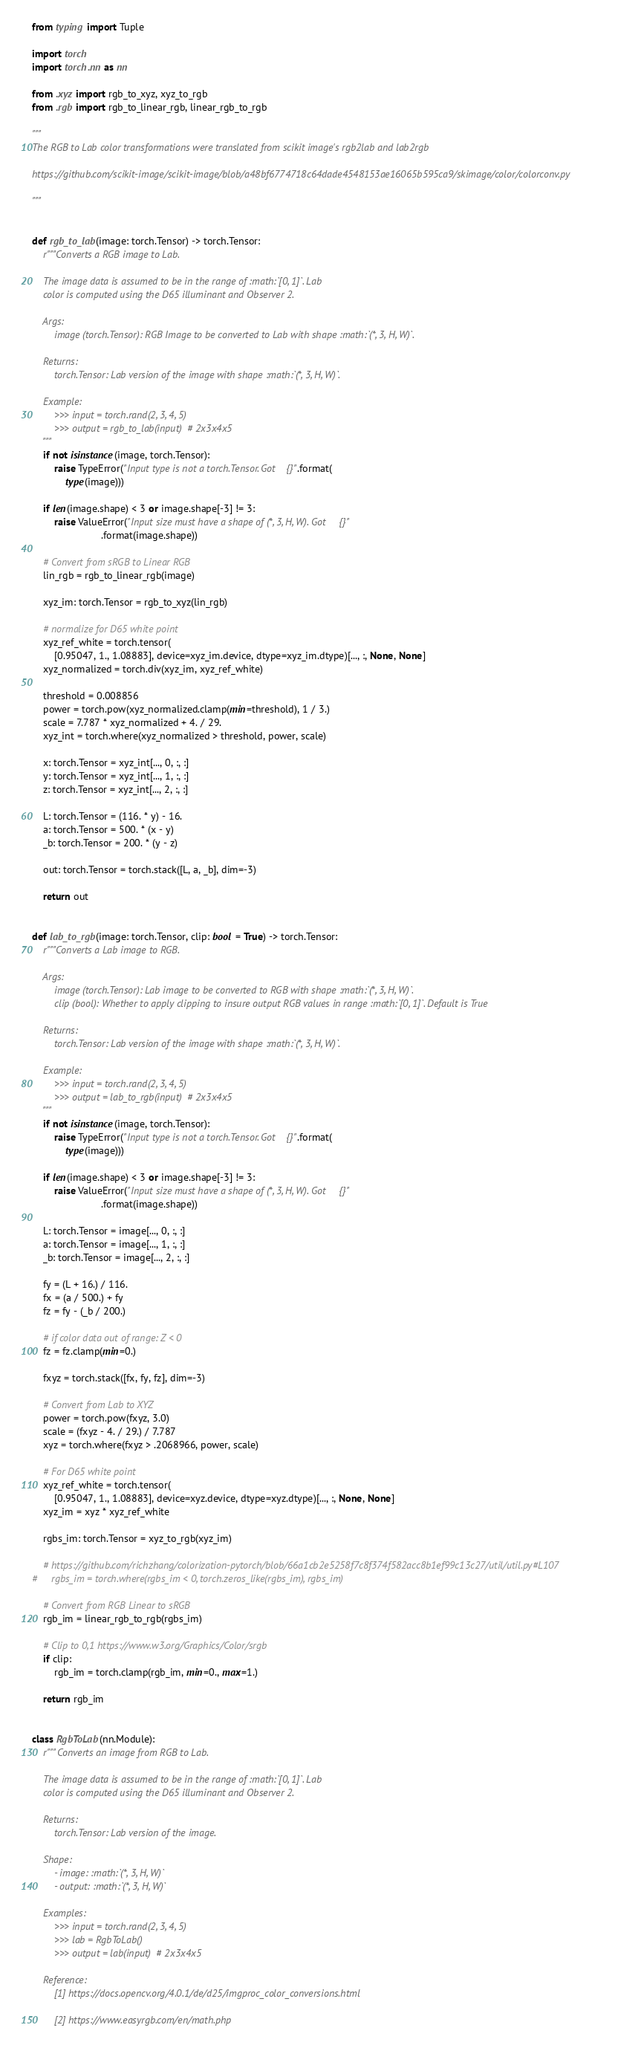<code> <loc_0><loc_0><loc_500><loc_500><_Python_>from typing import Tuple

import torch
import torch.nn as nn

from .xyz import rgb_to_xyz, xyz_to_rgb
from .rgb import rgb_to_linear_rgb, linear_rgb_to_rgb

"""
The RGB to Lab color transformations were translated from scikit image's rgb2lab and lab2rgb

https://github.com/scikit-image/scikit-image/blob/a48bf6774718c64dade4548153ae16065b595ca9/skimage/color/colorconv.py

"""


def rgb_to_lab(image: torch.Tensor) -> torch.Tensor:
    r"""Converts a RGB image to Lab.

    The image data is assumed to be in the range of :math:`[0, 1]`. Lab
    color is computed using the D65 illuminant and Observer 2.

    Args:
        image (torch.Tensor): RGB Image to be converted to Lab with shape :math:`(*, 3, H, W)`.

    Returns:
        torch.Tensor: Lab version of the image with shape :math:`(*, 3, H, W)`.

    Example:
        >>> input = torch.rand(2, 3, 4, 5)
        >>> output = rgb_to_lab(input)  # 2x3x4x5
    """
    if not isinstance(image, torch.Tensor):
        raise TypeError("Input type is not a torch.Tensor. Got {}".format(
            type(image)))

    if len(image.shape) < 3 or image.shape[-3] != 3:
        raise ValueError("Input size must have a shape of (*, 3, H, W). Got {}"
                         .format(image.shape))

    # Convert from sRGB to Linear RGB
    lin_rgb = rgb_to_linear_rgb(image)

    xyz_im: torch.Tensor = rgb_to_xyz(lin_rgb)

    # normalize for D65 white point
    xyz_ref_white = torch.tensor(
        [0.95047, 1., 1.08883], device=xyz_im.device, dtype=xyz_im.dtype)[..., :, None, None]
    xyz_normalized = torch.div(xyz_im, xyz_ref_white)

    threshold = 0.008856
    power = torch.pow(xyz_normalized.clamp(min=threshold), 1 / 3.)
    scale = 7.787 * xyz_normalized + 4. / 29.
    xyz_int = torch.where(xyz_normalized > threshold, power, scale)

    x: torch.Tensor = xyz_int[..., 0, :, :]
    y: torch.Tensor = xyz_int[..., 1, :, :]
    z: torch.Tensor = xyz_int[..., 2, :, :]

    L: torch.Tensor = (116. * y) - 16.
    a: torch.Tensor = 500. * (x - y)
    _b: torch.Tensor = 200. * (y - z)

    out: torch.Tensor = torch.stack([L, a, _b], dim=-3)

    return out


def lab_to_rgb(image: torch.Tensor, clip: bool = True) -> torch.Tensor:
    r"""Converts a Lab image to RGB.

    Args:
        image (torch.Tensor): Lab image to be converted to RGB with shape :math:`(*, 3, H, W)`.
        clip (bool): Whether to apply clipping to insure output RGB values in range :math:`[0, 1]`. Default is True

    Returns:
        torch.Tensor: Lab version of the image with shape :math:`(*, 3, H, W)`.

    Example:
        >>> input = torch.rand(2, 3, 4, 5)
        >>> output = lab_to_rgb(input)  # 2x3x4x5
    """
    if not isinstance(image, torch.Tensor):
        raise TypeError("Input type is not a torch.Tensor. Got {}".format(
            type(image)))

    if len(image.shape) < 3 or image.shape[-3] != 3:
        raise ValueError("Input size must have a shape of (*, 3, H, W). Got {}"
                         .format(image.shape))

    L: torch.Tensor = image[..., 0, :, :]
    a: torch.Tensor = image[..., 1, :, :]
    _b: torch.Tensor = image[..., 2, :, :]

    fy = (L + 16.) / 116.
    fx = (a / 500.) + fy
    fz = fy - (_b / 200.)

    # if color data out of range: Z < 0
    fz = fz.clamp(min=0.)

    fxyz = torch.stack([fx, fy, fz], dim=-3)

    # Convert from Lab to XYZ
    power = torch.pow(fxyz, 3.0)
    scale = (fxyz - 4. / 29.) / 7.787
    xyz = torch.where(fxyz > .2068966, power, scale)

    # For D65 white point
    xyz_ref_white = torch.tensor(
        [0.95047, 1., 1.08883], device=xyz.device, dtype=xyz.dtype)[..., :, None, None]
    xyz_im = xyz * xyz_ref_white

    rgbs_im: torch.Tensor = xyz_to_rgb(xyz_im)

    # https://github.com/richzhang/colorization-pytorch/blob/66a1cb2e5258f7c8f374f582acc8b1ef99c13c27/util/util.py#L107
#     rgbs_im = torch.where(rgbs_im < 0, torch.zeros_like(rgbs_im), rgbs_im)

    # Convert from RGB Linear to sRGB
    rgb_im = linear_rgb_to_rgb(rgbs_im)

    # Clip to 0,1 https://www.w3.org/Graphics/Color/srgb
    if clip:
        rgb_im = torch.clamp(rgb_im, min=0., max=1.)

    return rgb_im


class RgbToLab(nn.Module):
    r"""Converts an image from RGB to Lab.

    The image data is assumed to be in the range of :math:`[0, 1]`. Lab
    color is computed using the D65 illuminant and Observer 2.

    Returns:
        torch.Tensor: Lab version of the image.

    Shape:
        - image: :math:`(*, 3, H, W)`
        - output: :math:`(*, 3, H, W)`

    Examples:
        >>> input = torch.rand(2, 3, 4, 5)
        >>> lab = RgbToLab()
        >>> output = lab(input)  # 2x3x4x5

    Reference:
        [1] https://docs.opencv.org/4.0.1/de/d25/imgproc_color_conversions.html

        [2] https://www.easyrgb.com/en/math.php
</code> 